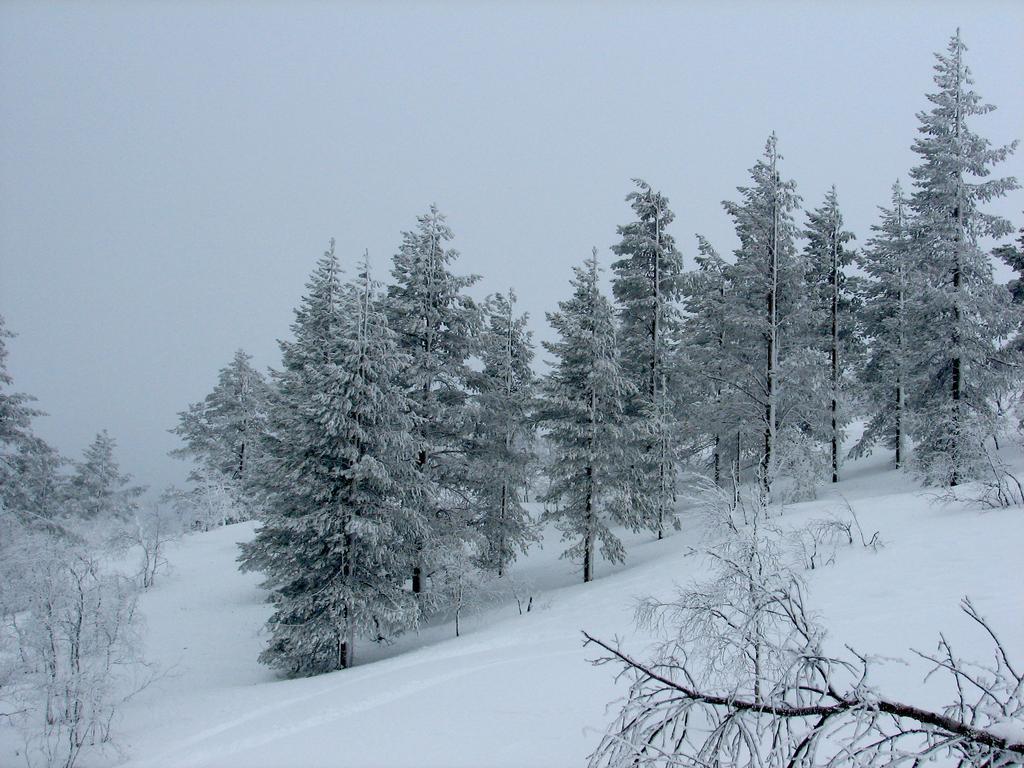In one or two sentences, can you explain what this image depicts? In this image we can see trees and snow. In the background there is sky. 